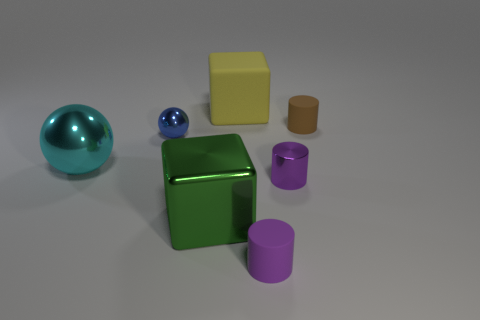Add 2 green shiny cubes. How many objects exist? 9 Subtract all spheres. How many objects are left? 5 Subtract all small purple objects. Subtract all cylinders. How many objects are left? 2 Add 3 small rubber cylinders. How many small rubber cylinders are left? 5 Add 3 green metallic things. How many green metallic things exist? 4 Subtract 0 gray cylinders. How many objects are left? 7 